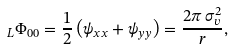<formula> <loc_0><loc_0><loc_500><loc_500>_ { L } \Phi _ { 0 0 } = \frac { 1 } { 2 } \left ( \psi _ { x x } + \psi _ { y y } \right ) = \frac { 2 \pi \, \sigma _ { v } ^ { 2 } } { r } ,</formula> 